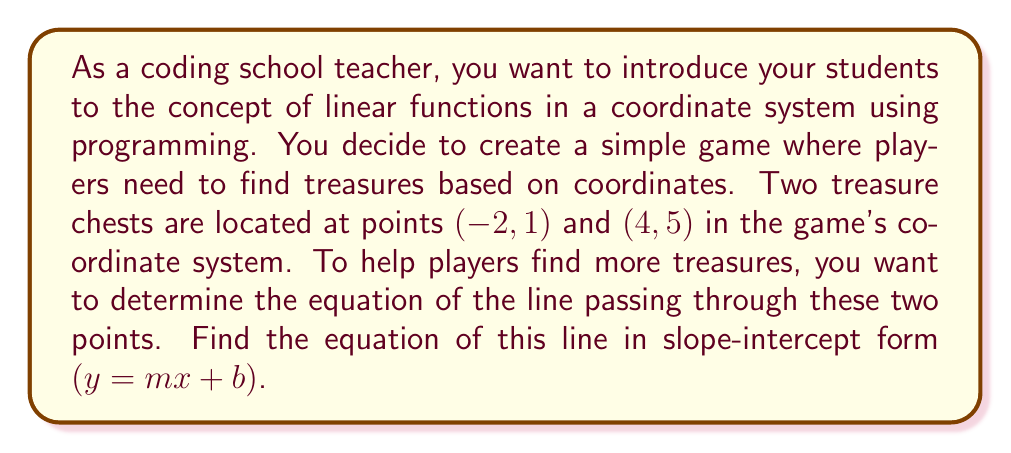Show me your answer to this math problem. To find the equation of a line passing through two points, we can follow these steps:

1. Calculate the slope $(m)$ using the slope formula:
   $$m = \frac{y_2 - y_1}{x_2 - x_1}$$
   where $(x_1, y_1)$ is the first point and $(x_2, y_2)$ is the second point.

2. Substitute the slope and one of the points into the point-slope form of a line:
   $$y - y_1 = m(x - x_1)$$

3. Simplify and rearrange the equation to get the slope-intercept form:
   $$y = mx + b$$

Let's apply these steps to our problem:

1. Calculate the slope:
   $$m = \frac{y_2 - y_1}{x_2 - x_1} = \frac{5 - 1}{4 - (-2)} = \frac{4}{6} = \frac{2}{3}$$

2. Use the point-slope form with the point $(-2, 1)$:
   $$y - 1 = \frac{2}{3}(x - (-2))$$
   $$y - 1 = \frac{2}{3}(x + 2)$$

3. Simplify and rearrange:
   $$y - 1 = \frac{2}{3}x + \frac{4}{3}$$
   $$y = \frac{2}{3}x + \frac{4}{3} + 1$$
   $$y = \frac{2}{3}x + \frac{7}{3}$$

Therefore, the equation of the line in slope-intercept form is $y = \frac{2}{3}x + \frac{7}{3}$.
Answer: $y = \frac{2}{3}x + \frac{7}{3}$ 